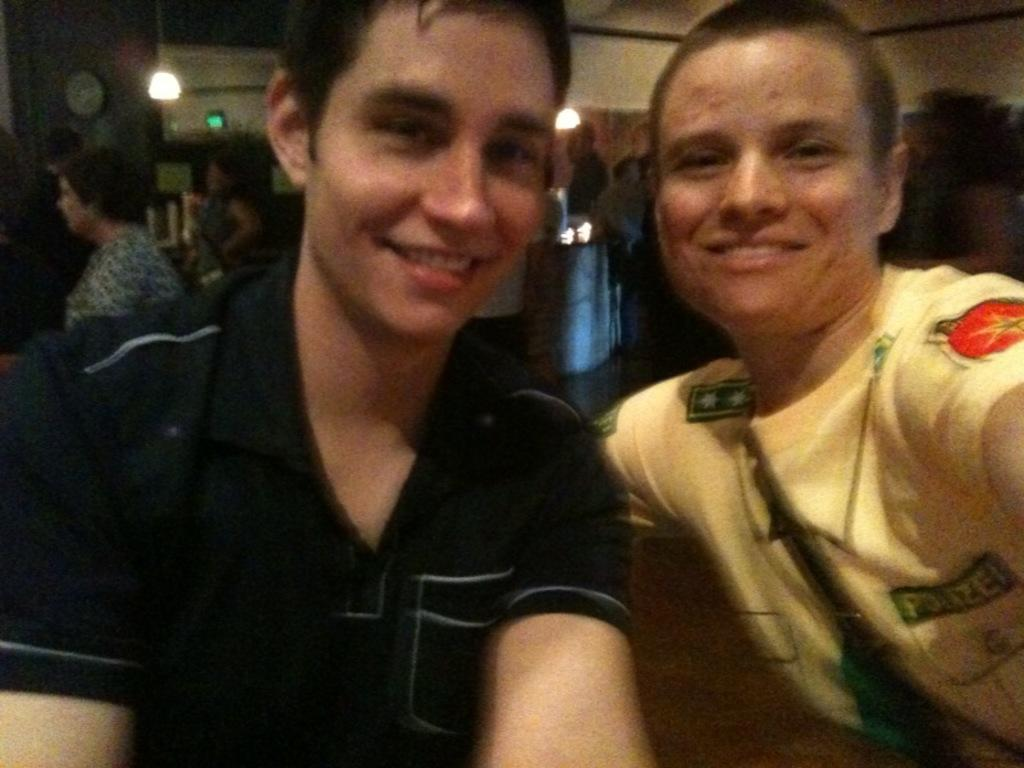What are the men in the image doing? The men in the image are sitting and smiling. What can be seen in the background of the image? In the background, there are people sitting and standing, as well as electric lights and objects arranged in cupboards. How many people are visible in the image? There are at least the men sitting and smiling, as well as the people in the background, so there are multiple people visible. What type of animals can be seen at the zoo in the image? There is no zoo present in the image, so it is not possible to determine what type of animals might be seen there. 